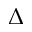<formula> <loc_0><loc_0><loc_500><loc_500>\Delta</formula> 